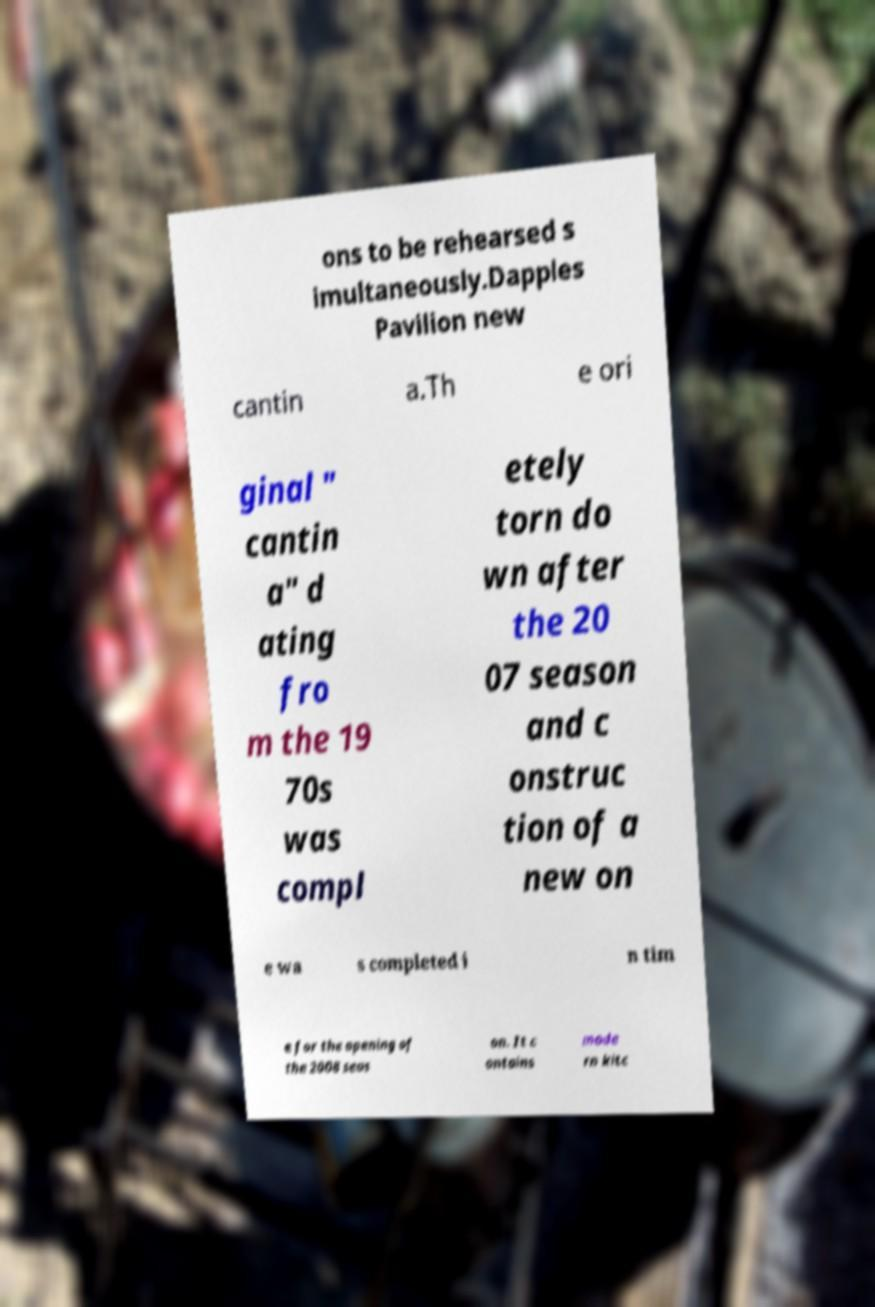For documentation purposes, I need the text within this image transcribed. Could you provide that? ons to be rehearsed s imultaneously.Dapples Pavilion new cantin a.Th e ori ginal " cantin a" d ating fro m the 19 70s was compl etely torn do wn after the 20 07 season and c onstruc tion of a new on e wa s completed i n tim e for the opening of the 2008 seas on. It c ontains mode rn kitc 